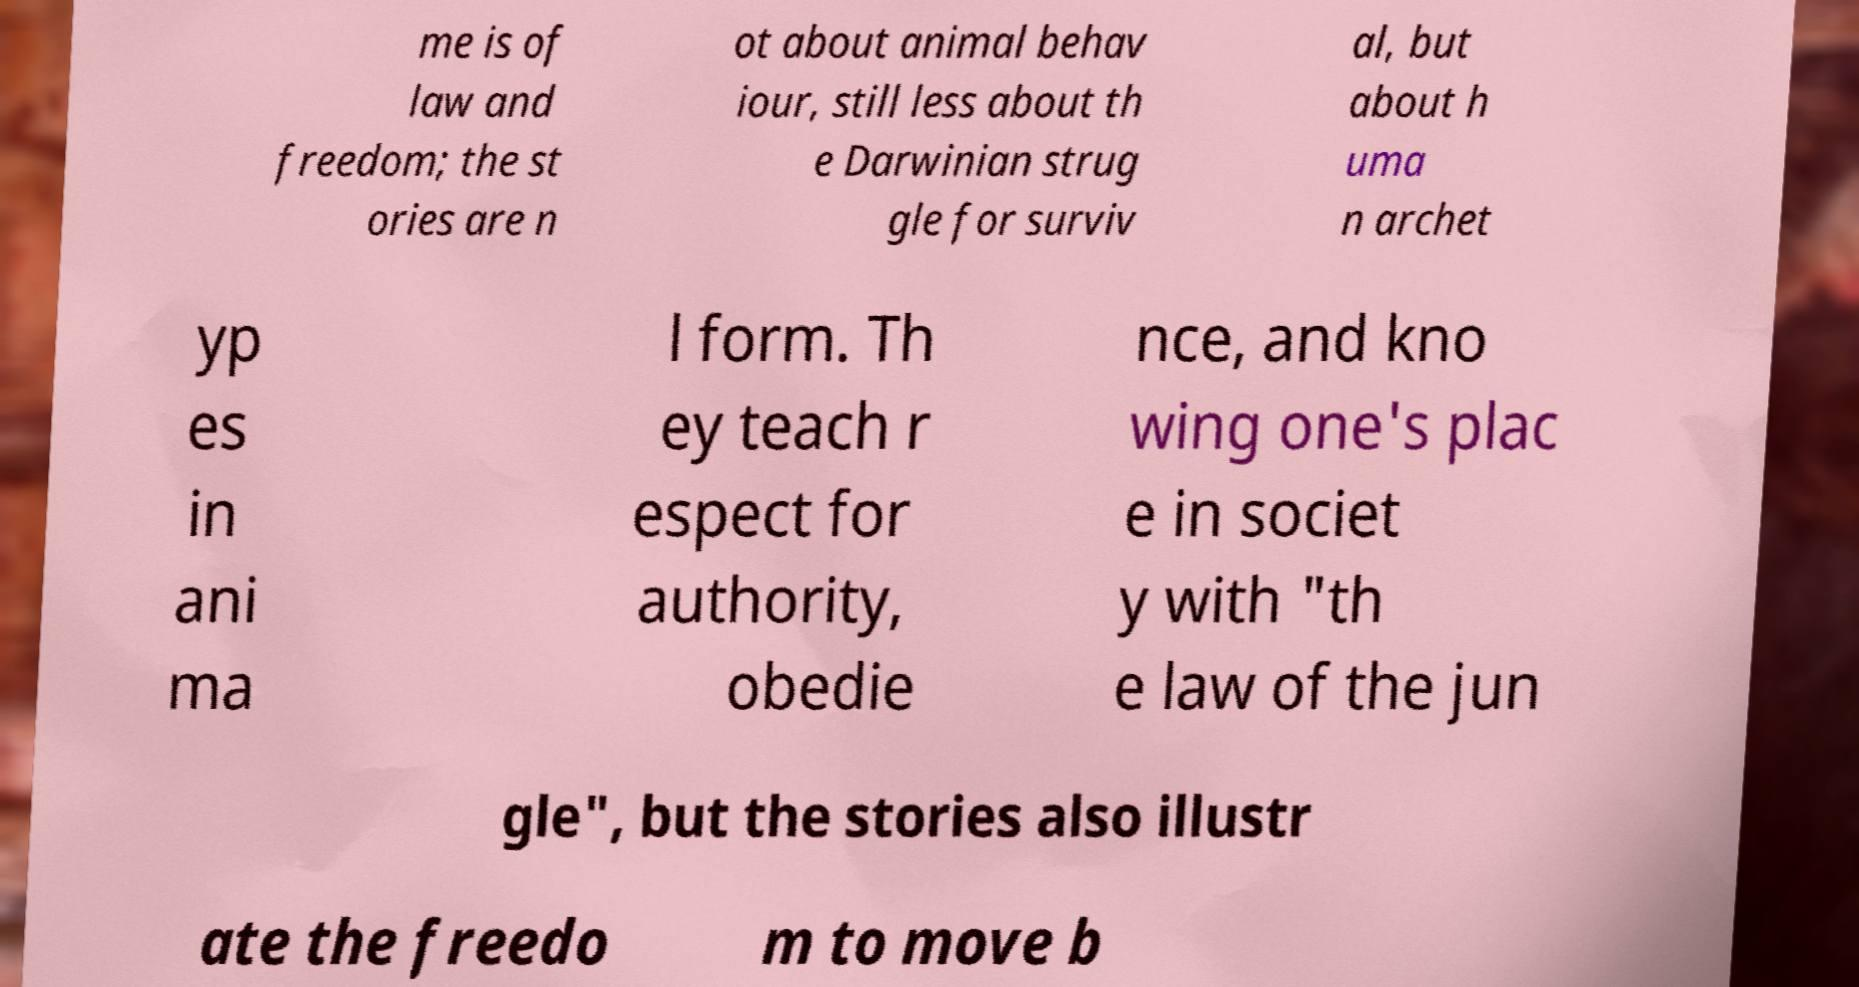For documentation purposes, I need the text within this image transcribed. Could you provide that? me is of law and freedom; the st ories are n ot about animal behav iour, still less about th e Darwinian strug gle for surviv al, but about h uma n archet yp es in ani ma l form. Th ey teach r espect for authority, obedie nce, and kno wing one's plac e in societ y with "th e law of the jun gle", but the stories also illustr ate the freedo m to move b 